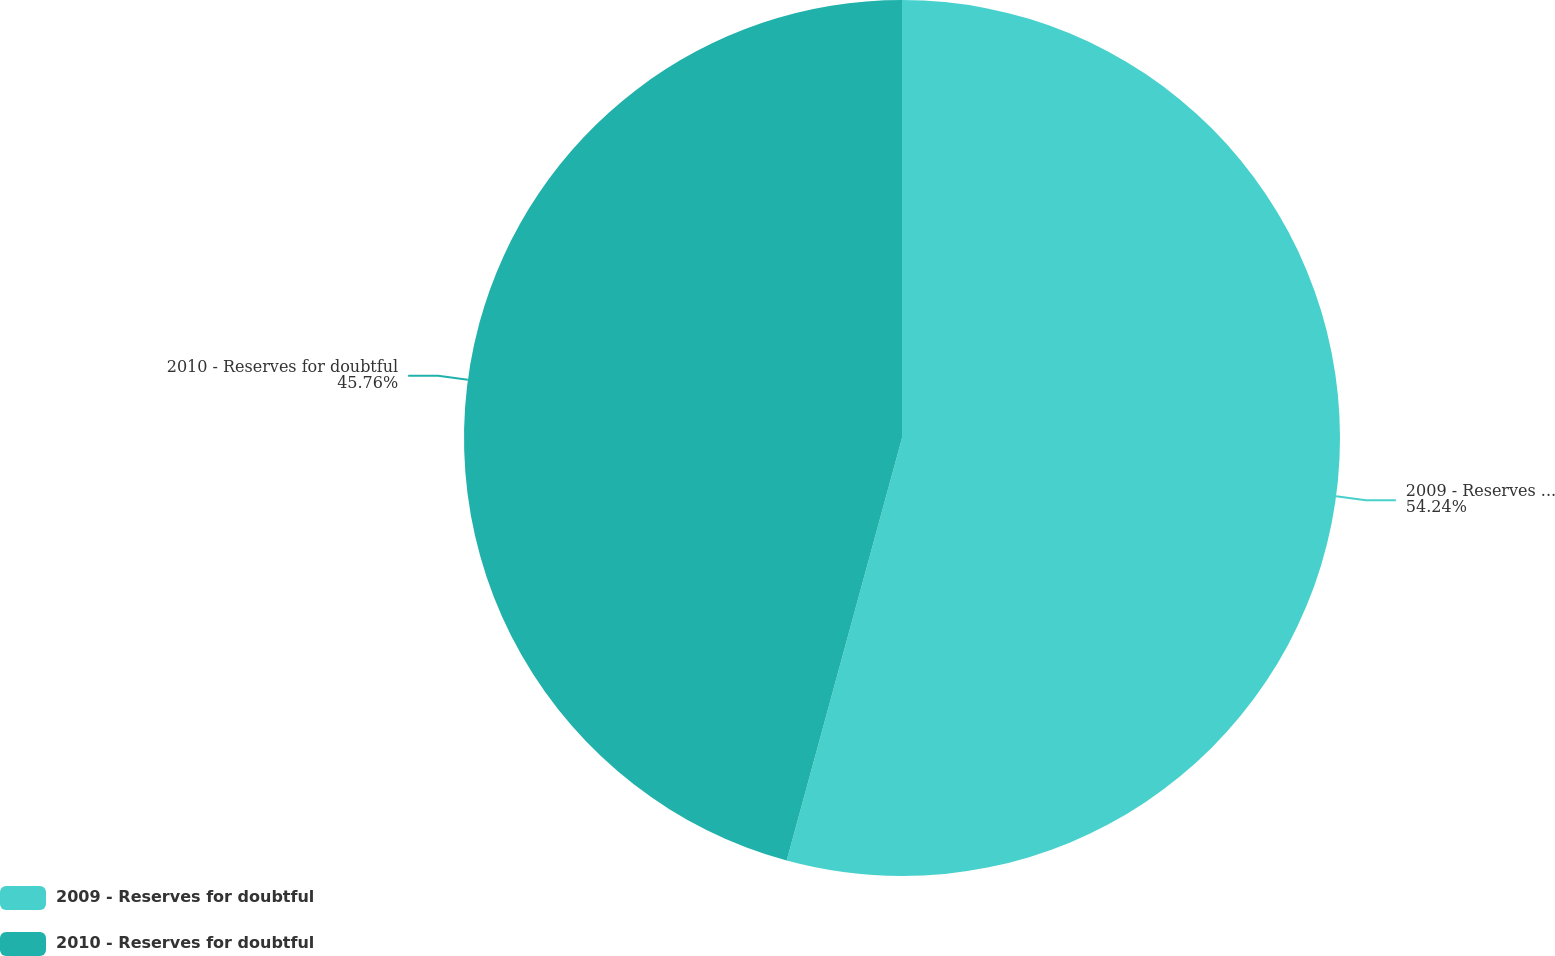Convert chart to OTSL. <chart><loc_0><loc_0><loc_500><loc_500><pie_chart><fcel>2009 - Reserves for doubtful<fcel>2010 - Reserves for doubtful<nl><fcel>54.24%<fcel>45.76%<nl></chart> 